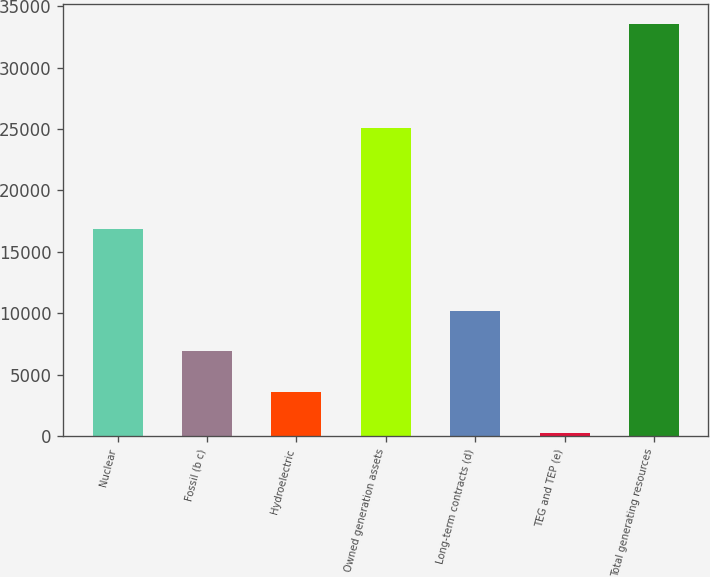Convert chart to OTSL. <chart><loc_0><loc_0><loc_500><loc_500><bar_chart><fcel>Nuclear<fcel>Fossil (b c)<fcel>Hydroelectric<fcel>Owned generation assets<fcel>Long-term contracts (d)<fcel>TEG and TEP (e)<fcel>Total generating resources<nl><fcel>16856<fcel>6888<fcel>3559<fcel>25099<fcel>10217<fcel>230<fcel>33520<nl></chart> 